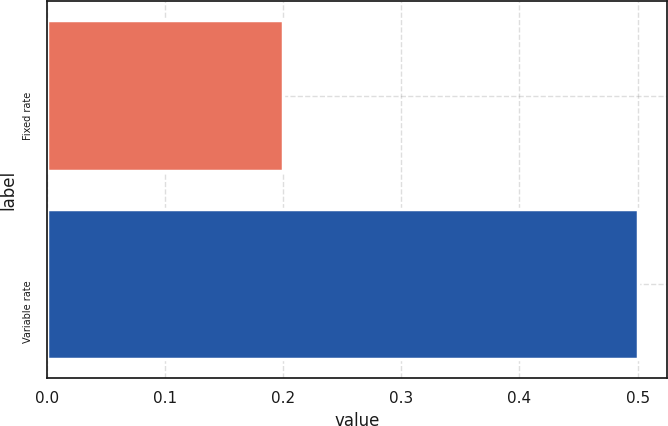Convert chart. <chart><loc_0><loc_0><loc_500><loc_500><bar_chart><fcel>Fixed rate<fcel>Variable rate<nl><fcel>0.2<fcel>0.5<nl></chart> 